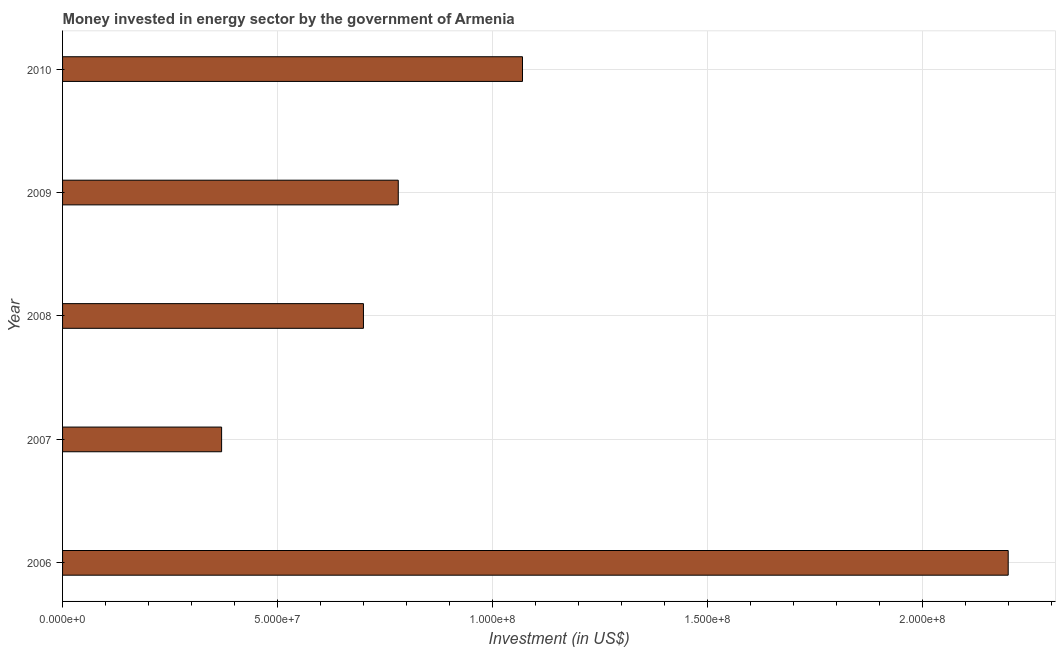Does the graph contain any zero values?
Provide a succinct answer. No. Does the graph contain grids?
Offer a very short reply. Yes. What is the title of the graph?
Your answer should be compact. Money invested in energy sector by the government of Armenia. What is the label or title of the X-axis?
Provide a short and direct response. Investment (in US$). What is the investment in energy in 2009?
Provide a short and direct response. 7.81e+07. Across all years, what is the maximum investment in energy?
Your answer should be compact. 2.20e+08. Across all years, what is the minimum investment in energy?
Provide a succinct answer. 3.70e+07. In which year was the investment in energy minimum?
Provide a succinct answer. 2007. What is the sum of the investment in energy?
Ensure brevity in your answer.  5.12e+08. What is the difference between the investment in energy in 2009 and 2010?
Keep it short and to the point. -2.89e+07. What is the average investment in energy per year?
Your answer should be very brief. 1.02e+08. What is the median investment in energy?
Your answer should be compact. 7.81e+07. What is the ratio of the investment in energy in 2007 to that in 2009?
Your response must be concise. 0.47. What is the difference between the highest and the second highest investment in energy?
Your response must be concise. 1.13e+08. What is the difference between the highest and the lowest investment in energy?
Your answer should be compact. 1.83e+08. How many years are there in the graph?
Give a very brief answer. 5. What is the Investment (in US$) of 2006?
Offer a very short reply. 2.20e+08. What is the Investment (in US$) in 2007?
Keep it short and to the point. 3.70e+07. What is the Investment (in US$) of 2008?
Provide a succinct answer. 7.00e+07. What is the Investment (in US$) in 2009?
Give a very brief answer. 7.81e+07. What is the Investment (in US$) of 2010?
Keep it short and to the point. 1.07e+08. What is the difference between the Investment (in US$) in 2006 and 2007?
Your response must be concise. 1.83e+08. What is the difference between the Investment (in US$) in 2006 and 2008?
Give a very brief answer. 1.50e+08. What is the difference between the Investment (in US$) in 2006 and 2009?
Give a very brief answer. 1.42e+08. What is the difference between the Investment (in US$) in 2006 and 2010?
Ensure brevity in your answer.  1.13e+08. What is the difference between the Investment (in US$) in 2007 and 2008?
Your answer should be compact. -3.30e+07. What is the difference between the Investment (in US$) in 2007 and 2009?
Offer a terse response. -4.11e+07. What is the difference between the Investment (in US$) in 2007 and 2010?
Your answer should be very brief. -7.00e+07. What is the difference between the Investment (in US$) in 2008 and 2009?
Offer a terse response. -8.10e+06. What is the difference between the Investment (in US$) in 2008 and 2010?
Keep it short and to the point. -3.70e+07. What is the difference between the Investment (in US$) in 2009 and 2010?
Provide a short and direct response. -2.89e+07. What is the ratio of the Investment (in US$) in 2006 to that in 2007?
Offer a terse response. 5.95. What is the ratio of the Investment (in US$) in 2006 to that in 2008?
Your response must be concise. 3.14. What is the ratio of the Investment (in US$) in 2006 to that in 2009?
Your answer should be compact. 2.82. What is the ratio of the Investment (in US$) in 2006 to that in 2010?
Make the answer very short. 2.06. What is the ratio of the Investment (in US$) in 2007 to that in 2008?
Your answer should be compact. 0.53. What is the ratio of the Investment (in US$) in 2007 to that in 2009?
Provide a short and direct response. 0.47. What is the ratio of the Investment (in US$) in 2007 to that in 2010?
Your answer should be very brief. 0.35. What is the ratio of the Investment (in US$) in 2008 to that in 2009?
Make the answer very short. 0.9. What is the ratio of the Investment (in US$) in 2008 to that in 2010?
Provide a short and direct response. 0.65. What is the ratio of the Investment (in US$) in 2009 to that in 2010?
Your response must be concise. 0.73. 